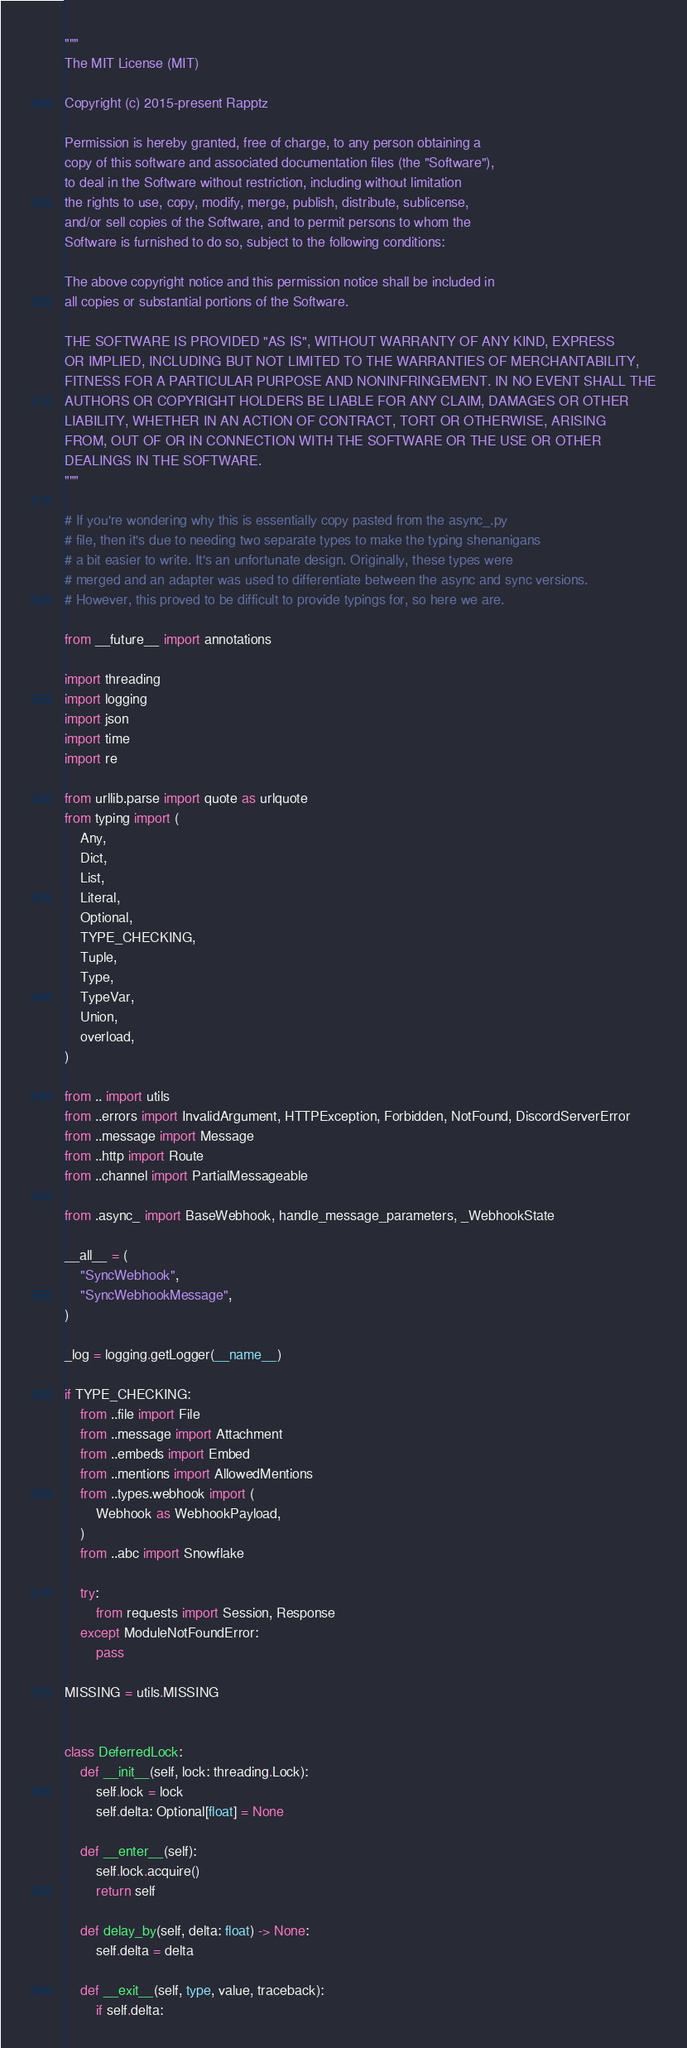Convert code to text. <code><loc_0><loc_0><loc_500><loc_500><_Python_>"""
The MIT License (MIT)

Copyright (c) 2015-present Rapptz

Permission is hereby granted, free of charge, to any person obtaining a
copy of this software and associated documentation files (the "Software"),
to deal in the Software without restriction, including without limitation
the rights to use, copy, modify, merge, publish, distribute, sublicense,
and/or sell copies of the Software, and to permit persons to whom the
Software is furnished to do so, subject to the following conditions:

The above copyright notice and this permission notice shall be included in
all copies or substantial portions of the Software.

THE SOFTWARE IS PROVIDED "AS IS", WITHOUT WARRANTY OF ANY KIND, EXPRESS
OR IMPLIED, INCLUDING BUT NOT LIMITED TO THE WARRANTIES OF MERCHANTABILITY,
FITNESS FOR A PARTICULAR PURPOSE AND NONINFRINGEMENT. IN NO EVENT SHALL THE
AUTHORS OR COPYRIGHT HOLDERS BE LIABLE FOR ANY CLAIM, DAMAGES OR OTHER
LIABILITY, WHETHER IN AN ACTION OF CONTRACT, TORT OR OTHERWISE, ARISING
FROM, OUT OF OR IN CONNECTION WITH THE SOFTWARE OR THE USE OR OTHER
DEALINGS IN THE SOFTWARE.
"""

# If you're wondering why this is essentially copy pasted from the async_.py
# file, then it's due to needing two separate types to make the typing shenanigans
# a bit easier to write. It's an unfortunate design. Originally, these types were
# merged and an adapter was used to differentiate between the async and sync versions.
# However, this proved to be difficult to provide typings for, so here we are.

from __future__ import annotations

import threading
import logging
import json
import time
import re

from urllib.parse import quote as urlquote
from typing import (
    Any,
    Dict,
    List,
    Literal,
    Optional,
    TYPE_CHECKING,
    Tuple,
    Type,
    TypeVar,
    Union,
    overload,
)

from .. import utils
from ..errors import InvalidArgument, HTTPException, Forbidden, NotFound, DiscordServerError
from ..message import Message
from ..http import Route
from ..channel import PartialMessageable

from .async_ import BaseWebhook, handle_message_parameters, _WebhookState

__all__ = (
    "SyncWebhook",
    "SyncWebhookMessage",
)

_log = logging.getLogger(__name__)

if TYPE_CHECKING:
    from ..file import File
    from ..message import Attachment
    from ..embeds import Embed
    from ..mentions import AllowedMentions
    from ..types.webhook import (
        Webhook as WebhookPayload,
    )
    from ..abc import Snowflake

    try:
        from requests import Session, Response
    except ModuleNotFoundError:
        pass

MISSING = utils.MISSING


class DeferredLock:
    def __init__(self, lock: threading.Lock):
        self.lock = lock
        self.delta: Optional[float] = None

    def __enter__(self):
        self.lock.acquire()
        return self

    def delay_by(self, delta: float) -> None:
        self.delta = delta

    def __exit__(self, type, value, traceback):
        if self.delta:</code> 